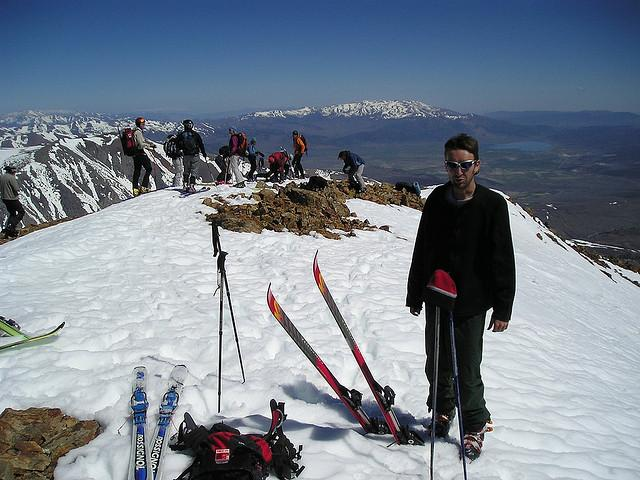How will everyone get off the top of the mountain?

Choices:
A) belay
B) jet ski
C) ropes
D) ski ski 